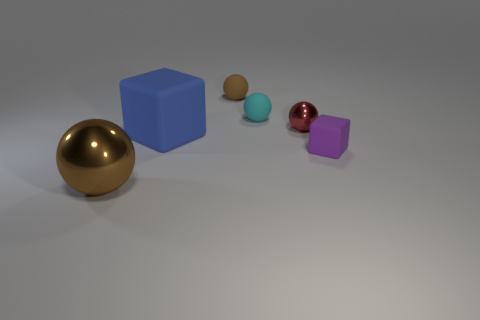Is the color of the shiny thing that is left of the large rubber thing the same as the tiny rubber cube?
Your answer should be compact. No. Are the purple cube and the big ball made of the same material?
Give a very brief answer. No. Are there the same number of tiny cyan rubber things on the left side of the brown shiny sphere and big matte things that are on the right side of the brown matte thing?
Offer a very short reply. Yes. There is another brown object that is the same shape as the brown matte object; what is its material?
Ensure brevity in your answer.  Metal. What shape is the tiny rubber thing to the left of the matte sphere that is in front of the brown ball behind the tiny purple block?
Offer a very short reply. Sphere. Are there more tiny balls that are left of the small red sphere than large red rubber cylinders?
Ensure brevity in your answer.  Yes. There is a metallic object behind the small purple cube; is its shape the same as the brown metal thing?
Provide a succinct answer. Yes. There is a brown object in front of the small metal object; what is its material?
Provide a short and direct response. Metal. What number of big brown objects have the same shape as the blue rubber thing?
Offer a very short reply. 0. There is a brown thing in front of the metallic object that is on the right side of the brown shiny object; what is its material?
Provide a succinct answer. Metal. 